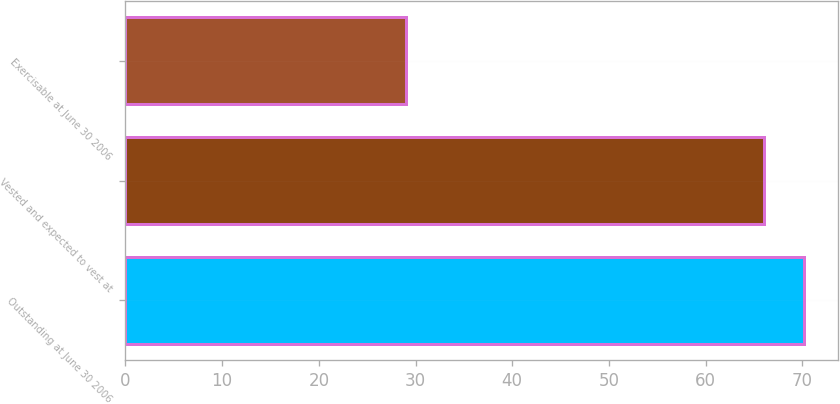Convert chart to OTSL. <chart><loc_0><loc_0><loc_500><loc_500><bar_chart><fcel>Outstanding at June 30 2006<fcel>Vested and expected to vest at<fcel>Exercisable at June 30 2006<nl><fcel>70.2<fcel>66<fcel>29<nl></chart> 